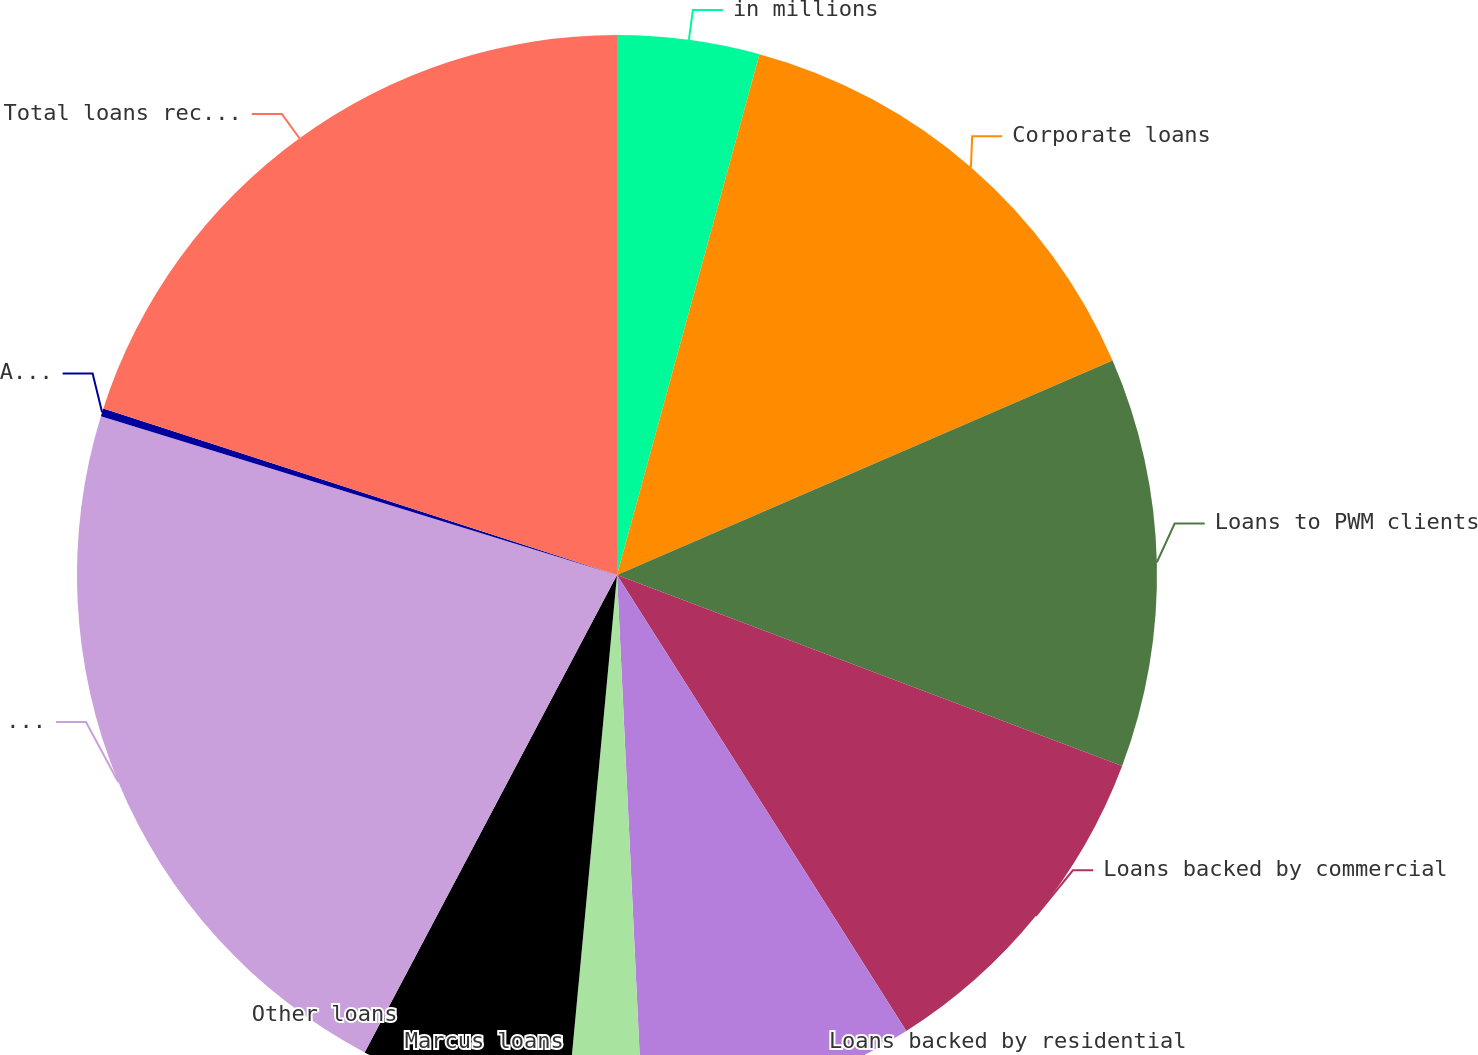<chart> <loc_0><loc_0><loc_500><loc_500><pie_chart><fcel>in millions<fcel>Corporate loans<fcel>Loans to PWM clients<fcel>Loans backed by commercial<fcel>Loans backed by residential<fcel>Marcus loans<fcel>Other loans<fcel>Total loans receivable gross<fcel>Allowance for loan losses<fcel>Total loans receivable<nl><fcel>4.25%<fcel>14.25%<fcel>12.25%<fcel>10.25%<fcel>8.25%<fcel>2.24%<fcel>6.25%<fcel>22.01%<fcel>0.24%<fcel>20.01%<nl></chart> 